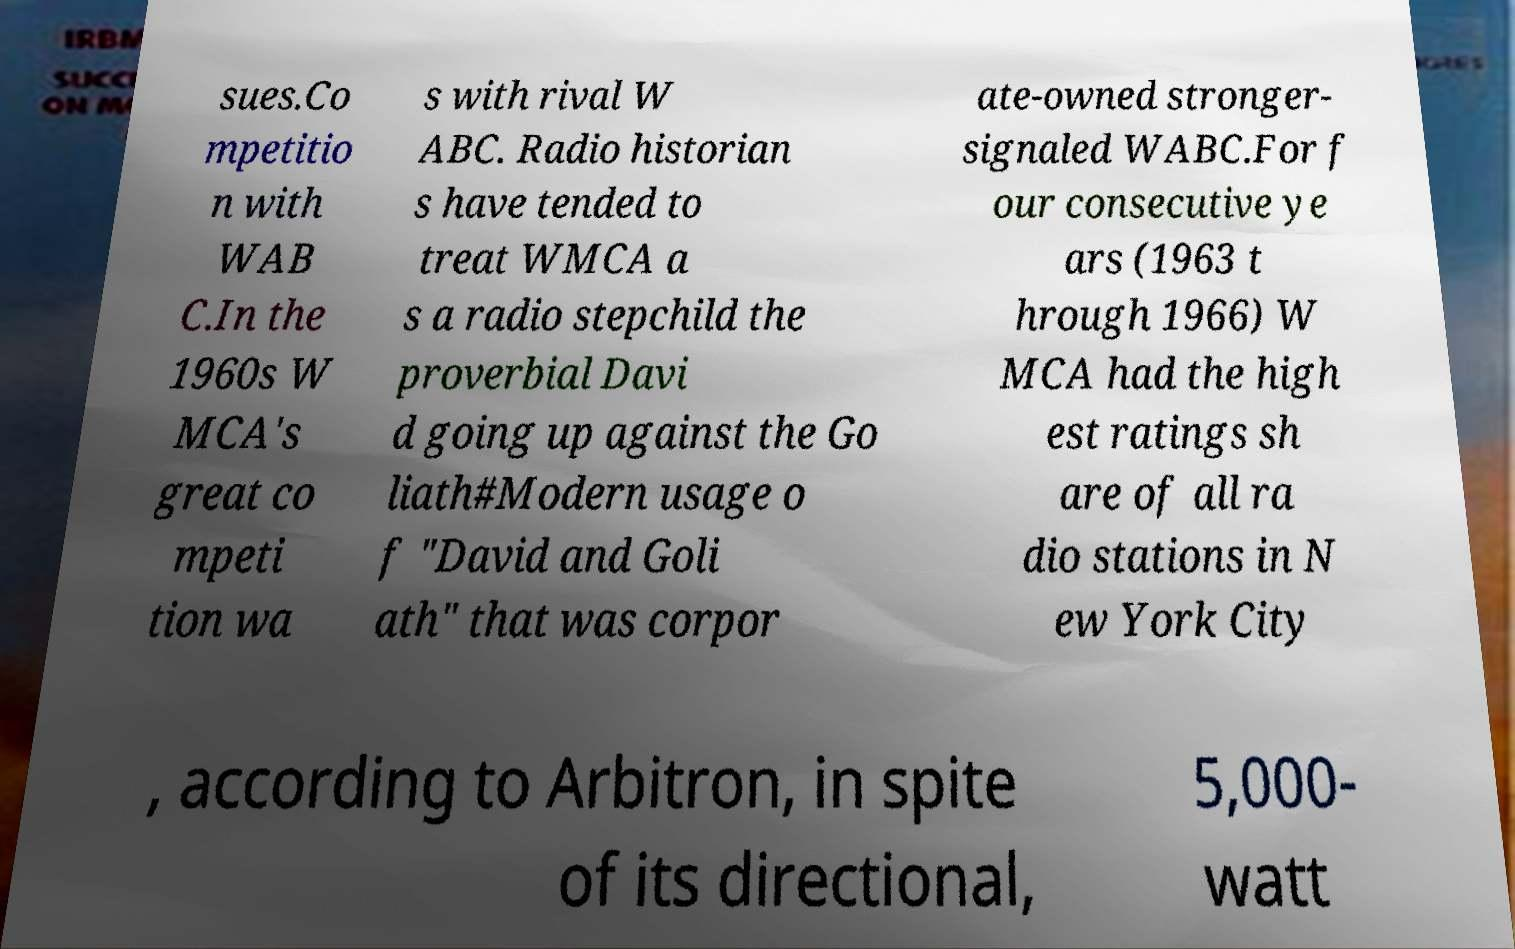Can you read and provide the text displayed in the image?This photo seems to have some interesting text. Can you extract and type it out for me? sues.Co mpetitio n with WAB C.In the 1960s W MCA's great co mpeti tion wa s with rival W ABC. Radio historian s have tended to treat WMCA a s a radio stepchild the proverbial Davi d going up against the Go liath#Modern usage o f "David and Goli ath" that was corpor ate-owned stronger- signaled WABC.For f our consecutive ye ars (1963 t hrough 1966) W MCA had the high est ratings sh are of all ra dio stations in N ew York City , according to Arbitron, in spite of its directional, 5,000- watt 